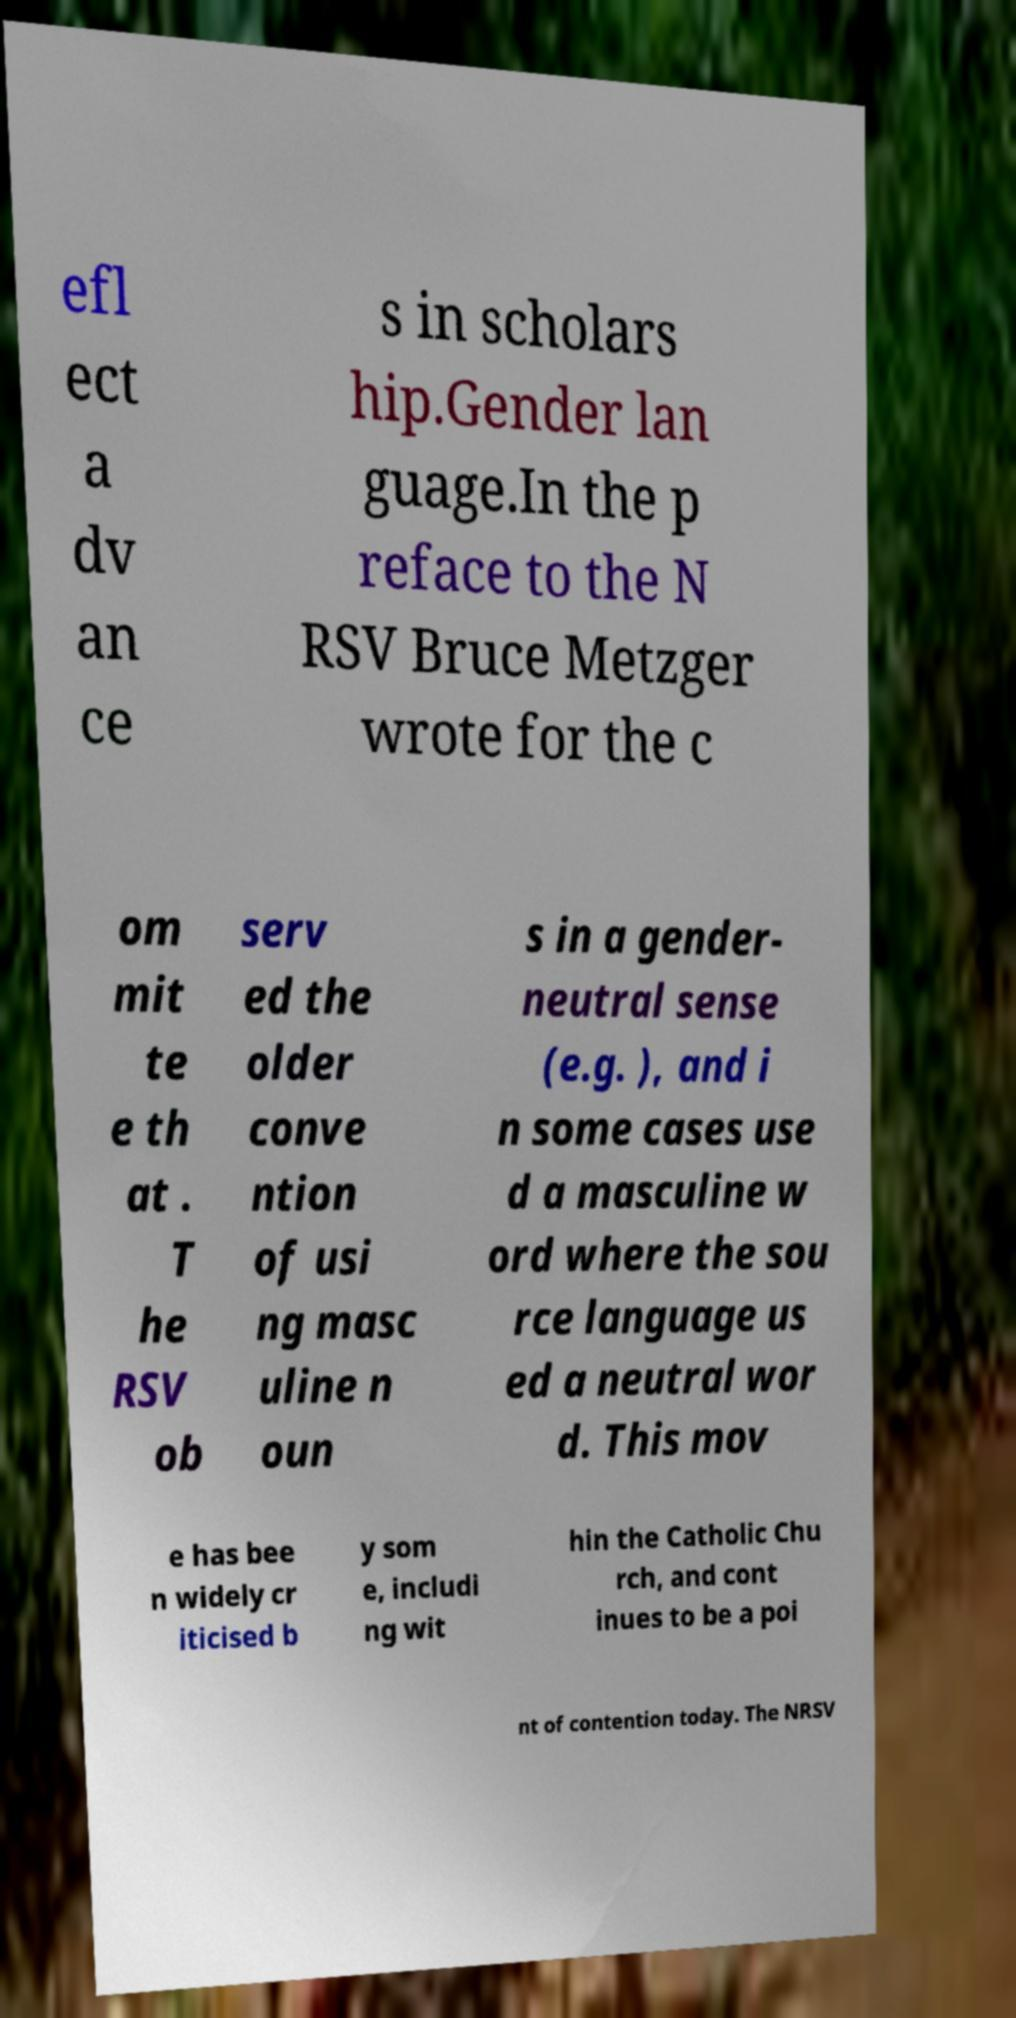There's text embedded in this image that I need extracted. Can you transcribe it verbatim? efl ect a dv an ce s in scholars hip.Gender lan guage.In the p reface to the N RSV Bruce Metzger wrote for the c om mit te e th at . T he RSV ob serv ed the older conve ntion of usi ng masc uline n oun s in a gender- neutral sense (e.g. ), and i n some cases use d a masculine w ord where the sou rce language us ed a neutral wor d. This mov e has bee n widely cr iticised b y som e, includi ng wit hin the Catholic Chu rch, and cont inues to be a poi nt of contention today. The NRSV 